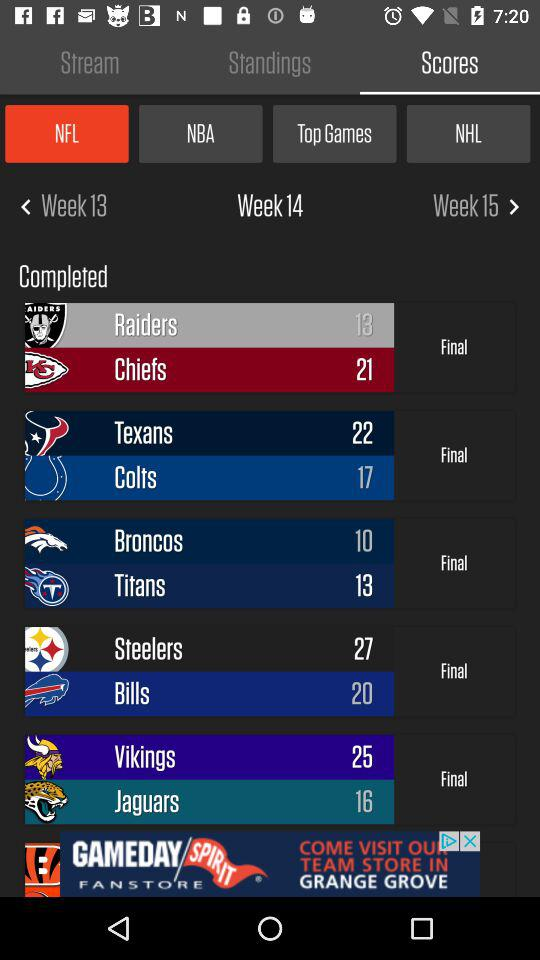What is the score of "Texans"? The score of "Texans" is 22. 